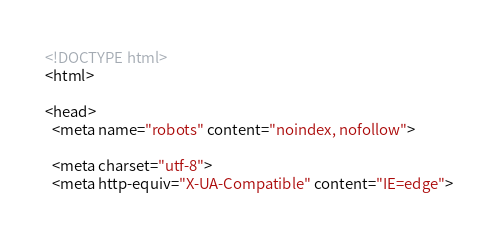<code> <loc_0><loc_0><loc_500><loc_500><_HTML_><!DOCTYPE html>
<html>

<head>
  <meta name="robots" content="noindex, nofollow">

  <meta charset="utf-8">
  <meta http-equiv="X-UA-Compatible" content="IE=edge"></code> 